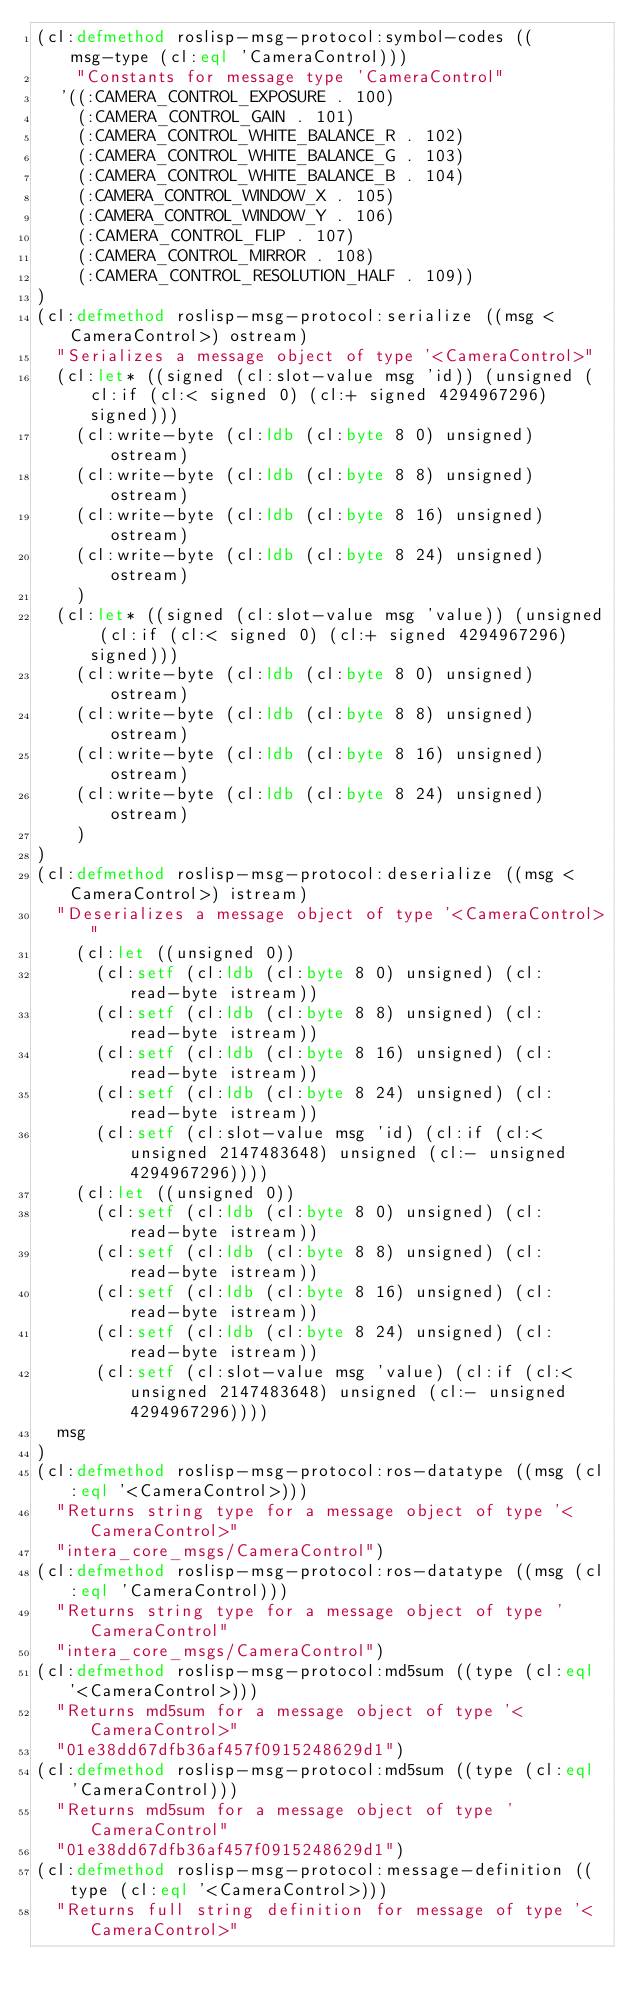Convert code to text. <code><loc_0><loc_0><loc_500><loc_500><_Lisp_>(cl:defmethod roslisp-msg-protocol:symbol-codes ((msg-type (cl:eql 'CameraControl)))
    "Constants for message type 'CameraControl"
  '((:CAMERA_CONTROL_EXPOSURE . 100)
    (:CAMERA_CONTROL_GAIN . 101)
    (:CAMERA_CONTROL_WHITE_BALANCE_R . 102)
    (:CAMERA_CONTROL_WHITE_BALANCE_G . 103)
    (:CAMERA_CONTROL_WHITE_BALANCE_B . 104)
    (:CAMERA_CONTROL_WINDOW_X . 105)
    (:CAMERA_CONTROL_WINDOW_Y . 106)
    (:CAMERA_CONTROL_FLIP . 107)
    (:CAMERA_CONTROL_MIRROR . 108)
    (:CAMERA_CONTROL_RESOLUTION_HALF . 109))
)
(cl:defmethod roslisp-msg-protocol:serialize ((msg <CameraControl>) ostream)
  "Serializes a message object of type '<CameraControl>"
  (cl:let* ((signed (cl:slot-value msg 'id)) (unsigned (cl:if (cl:< signed 0) (cl:+ signed 4294967296) signed)))
    (cl:write-byte (cl:ldb (cl:byte 8 0) unsigned) ostream)
    (cl:write-byte (cl:ldb (cl:byte 8 8) unsigned) ostream)
    (cl:write-byte (cl:ldb (cl:byte 8 16) unsigned) ostream)
    (cl:write-byte (cl:ldb (cl:byte 8 24) unsigned) ostream)
    )
  (cl:let* ((signed (cl:slot-value msg 'value)) (unsigned (cl:if (cl:< signed 0) (cl:+ signed 4294967296) signed)))
    (cl:write-byte (cl:ldb (cl:byte 8 0) unsigned) ostream)
    (cl:write-byte (cl:ldb (cl:byte 8 8) unsigned) ostream)
    (cl:write-byte (cl:ldb (cl:byte 8 16) unsigned) ostream)
    (cl:write-byte (cl:ldb (cl:byte 8 24) unsigned) ostream)
    )
)
(cl:defmethod roslisp-msg-protocol:deserialize ((msg <CameraControl>) istream)
  "Deserializes a message object of type '<CameraControl>"
    (cl:let ((unsigned 0))
      (cl:setf (cl:ldb (cl:byte 8 0) unsigned) (cl:read-byte istream))
      (cl:setf (cl:ldb (cl:byte 8 8) unsigned) (cl:read-byte istream))
      (cl:setf (cl:ldb (cl:byte 8 16) unsigned) (cl:read-byte istream))
      (cl:setf (cl:ldb (cl:byte 8 24) unsigned) (cl:read-byte istream))
      (cl:setf (cl:slot-value msg 'id) (cl:if (cl:< unsigned 2147483648) unsigned (cl:- unsigned 4294967296))))
    (cl:let ((unsigned 0))
      (cl:setf (cl:ldb (cl:byte 8 0) unsigned) (cl:read-byte istream))
      (cl:setf (cl:ldb (cl:byte 8 8) unsigned) (cl:read-byte istream))
      (cl:setf (cl:ldb (cl:byte 8 16) unsigned) (cl:read-byte istream))
      (cl:setf (cl:ldb (cl:byte 8 24) unsigned) (cl:read-byte istream))
      (cl:setf (cl:slot-value msg 'value) (cl:if (cl:< unsigned 2147483648) unsigned (cl:- unsigned 4294967296))))
  msg
)
(cl:defmethod roslisp-msg-protocol:ros-datatype ((msg (cl:eql '<CameraControl>)))
  "Returns string type for a message object of type '<CameraControl>"
  "intera_core_msgs/CameraControl")
(cl:defmethod roslisp-msg-protocol:ros-datatype ((msg (cl:eql 'CameraControl)))
  "Returns string type for a message object of type 'CameraControl"
  "intera_core_msgs/CameraControl")
(cl:defmethod roslisp-msg-protocol:md5sum ((type (cl:eql '<CameraControl>)))
  "Returns md5sum for a message object of type '<CameraControl>"
  "01e38dd67dfb36af457f0915248629d1")
(cl:defmethod roslisp-msg-protocol:md5sum ((type (cl:eql 'CameraControl)))
  "Returns md5sum for a message object of type 'CameraControl"
  "01e38dd67dfb36af457f0915248629d1")
(cl:defmethod roslisp-msg-protocol:message-definition ((type (cl:eql '<CameraControl>)))
  "Returns full string definition for message of type '<CameraControl>"</code> 